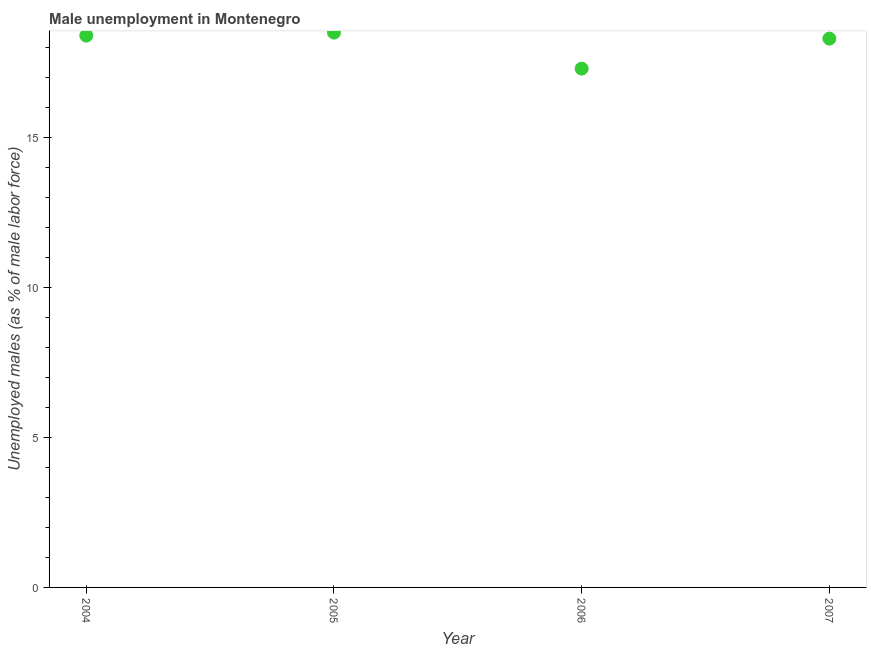What is the unemployed males population in 2006?
Provide a short and direct response. 17.3. Across all years, what is the maximum unemployed males population?
Ensure brevity in your answer.  18.5. Across all years, what is the minimum unemployed males population?
Give a very brief answer. 17.3. In which year was the unemployed males population maximum?
Offer a terse response. 2005. What is the sum of the unemployed males population?
Your response must be concise. 72.5. What is the difference between the unemployed males population in 2004 and 2005?
Your answer should be compact. -0.1. What is the average unemployed males population per year?
Offer a terse response. 18.12. What is the median unemployed males population?
Your answer should be very brief. 18.35. In how many years, is the unemployed males population greater than 8 %?
Your answer should be compact. 4. Do a majority of the years between 2007 and 2006 (inclusive) have unemployed males population greater than 2 %?
Keep it short and to the point. No. What is the ratio of the unemployed males population in 2005 to that in 2007?
Your answer should be very brief. 1.01. Is the unemployed males population in 2004 less than that in 2007?
Provide a succinct answer. No. What is the difference between the highest and the second highest unemployed males population?
Offer a very short reply. 0.1. What is the difference between the highest and the lowest unemployed males population?
Your response must be concise. 1.2. In how many years, is the unemployed males population greater than the average unemployed males population taken over all years?
Your answer should be very brief. 3. Does the unemployed males population monotonically increase over the years?
Give a very brief answer. No. How many dotlines are there?
Your response must be concise. 1. How many years are there in the graph?
Your answer should be compact. 4. Are the values on the major ticks of Y-axis written in scientific E-notation?
Your answer should be compact. No. What is the title of the graph?
Give a very brief answer. Male unemployment in Montenegro. What is the label or title of the Y-axis?
Your answer should be compact. Unemployed males (as % of male labor force). What is the Unemployed males (as % of male labor force) in 2004?
Make the answer very short. 18.4. What is the Unemployed males (as % of male labor force) in 2006?
Give a very brief answer. 17.3. What is the Unemployed males (as % of male labor force) in 2007?
Your response must be concise. 18.3. What is the difference between the Unemployed males (as % of male labor force) in 2004 and 2005?
Offer a terse response. -0.1. What is the difference between the Unemployed males (as % of male labor force) in 2004 and 2006?
Give a very brief answer. 1.1. What is the difference between the Unemployed males (as % of male labor force) in 2004 and 2007?
Keep it short and to the point. 0.1. What is the difference between the Unemployed males (as % of male labor force) in 2005 and 2006?
Make the answer very short. 1.2. What is the difference between the Unemployed males (as % of male labor force) in 2005 and 2007?
Your answer should be very brief. 0.2. What is the ratio of the Unemployed males (as % of male labor force) in 2004 to that in 2006?
Your answer should be compact. 1.06. What is the ratio of the Unemployed males (as % of male labor force) in 2004 to that in 2007?
Ensure brevity in your answer.  1. What is the ratio of the Unemployed males (as % of male labor force) in 2005 to that in 2006?
Your response must be concise. 1.07. What is the ratio of the Unemployed males (as % of male labor force) in 2005 to that in 2007?
Ensure brevity in your answer.  1.01. What is the ratio of the Unemployed males (as % of male labor force) in 2006 to that in 2007?
Offer a terse response. 0.94. 